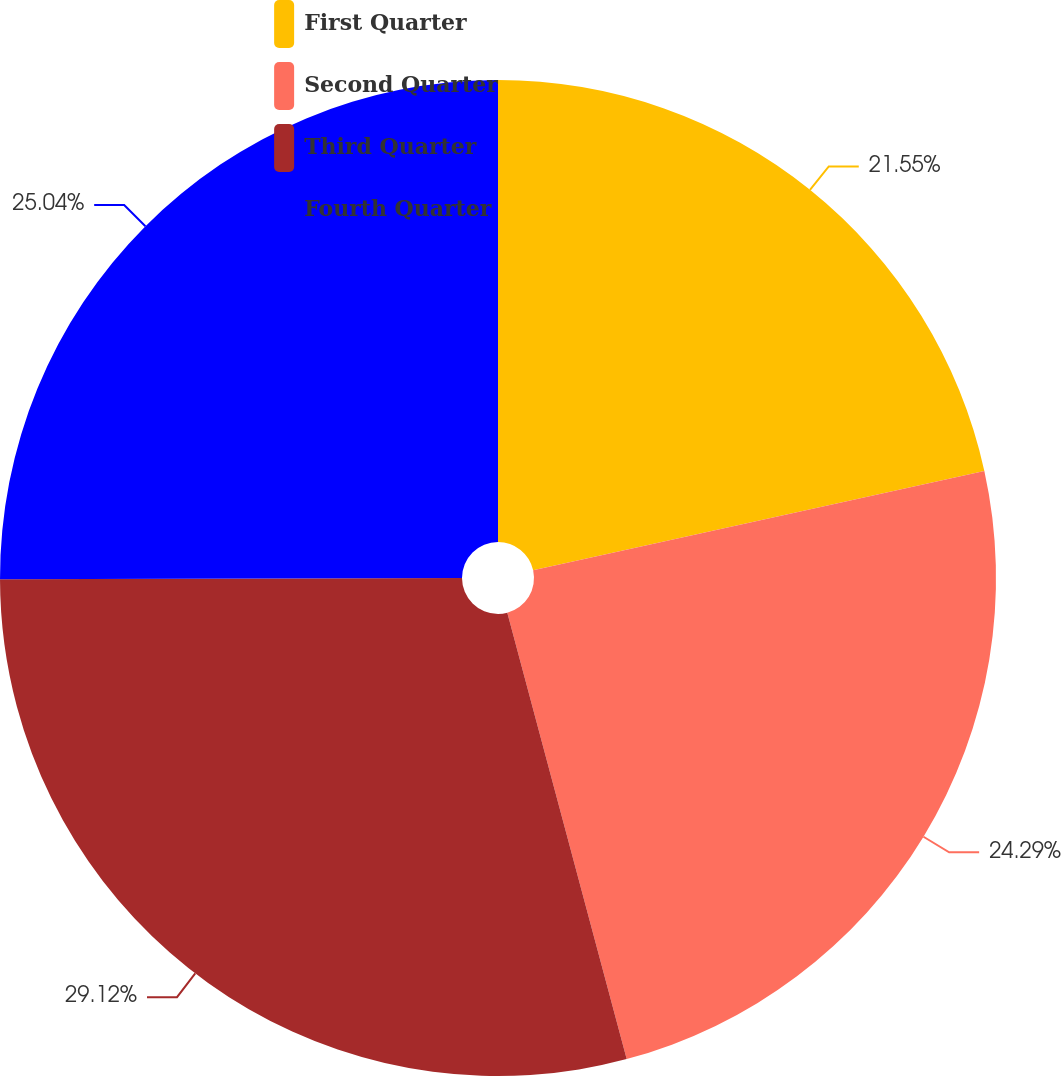<chart> <loc_0><loc_0><loc_500><loc_500><pie_chart><fcel>First Quarter<fcel>Second Quarter<fcel>Third Quarter<fcel>Fourth Quarter<nl><fcel>21.55%<fcel>24.29%<fcel>29.12%<fcel>25.04%<nl></chart> 